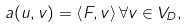<formula> <loc_0><loc_0><loc_500><loc_500>a ( u , v ) = \left \langle F , v \right \rangle \forall v \in V _ { D } ,</formula> 